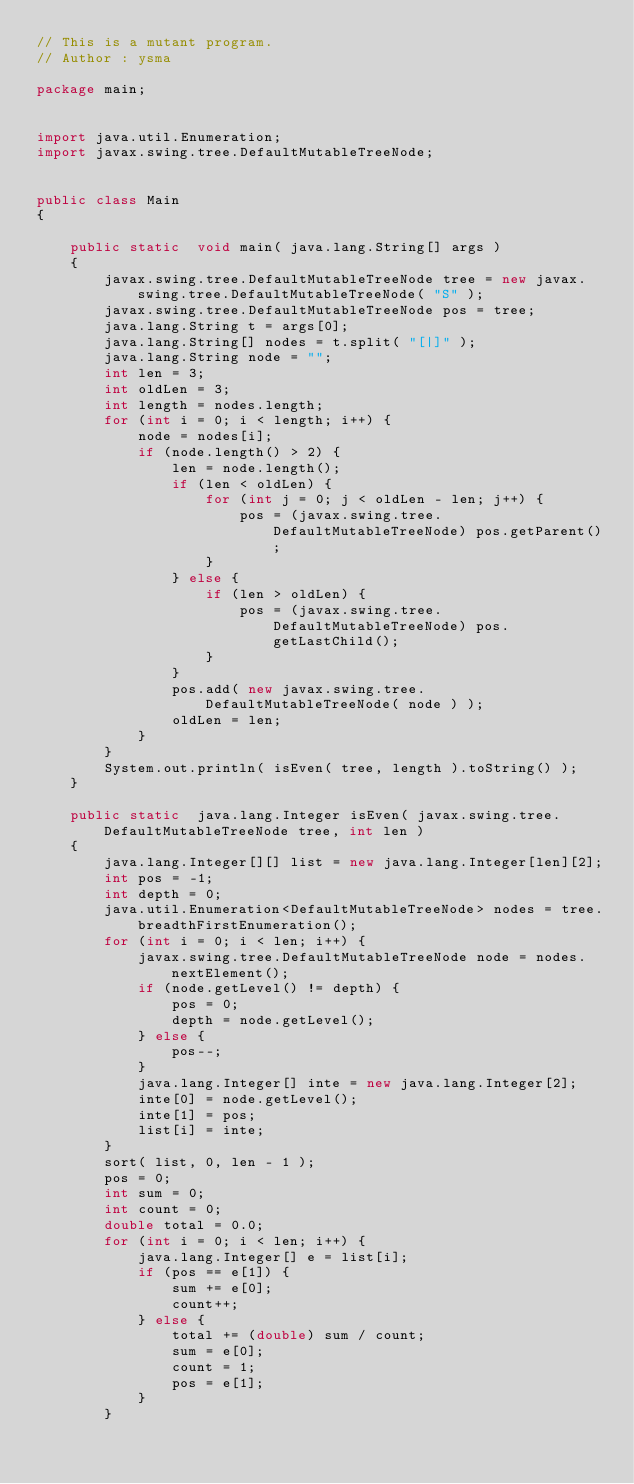Convert code to text. <code><loc_0><loc_0><loc_500><loc_500><_Java_>// This is a mutant program.
// Author : ysma

package main;


import java.util.Enumeration;
import javax.swing.tree.DefaultMutableTreeNode;


public class Main
{

    public static  void main( java.lang.String[] args )
    {
        javax.swing.tree.DefaultMutableTreeNode tree = new javax.swing.tree.DefaultMutableTreeNode( "S" );
        javax.swing.tree.DefaultMutableTreeNode pos = tree;
        java.lang.String t = args[0];
        java.lang.String[] nodes = t.split( "[|]" );
        java.lang.String node = "";
        int len = 3;
        int oldLen = 3;
        int length = nodes.length;
        for (int i = 0; i < length; i++) {
            node = nodes[i];
            if (node.length() > 2) {
                len = node.length();
                if (len < oldLen) {
                    for (int j = 0; j < oldLen - len; j++) {
                        pos = (javax.swing.tree.DefaultMutableTreeNode) pos.getParent();
                    }
                } else {
                    if (len > oldLen) {
                        pos = (javax.swing.tree.DefaultMutableTreeNode) pos.getLastChild();
                    }
                }
                pos.add( new javax.swing.tree.DefaultMutableTreeNode( node ) );
                oldLen = len;
            }
        }
        System.out.println( isEven( tree, length ).toString() );
    }

    public static  java.lang.Integer isEven( javax.swing.tree.DefaultMutableTreeNode tree, int len )
    {
        java.lang.Integer[][] list = new java.lang.Integer[len][2];
        int pos = -1;
        int depth = 0;
        java.util.Enumeration<DefaultMutableTreeNode> nodes = tree.breadthFirstEnumeration();
        for (int i = 0; i < len; i++) {
            javax.swing.tree.DefaultMutableTreeNode node = nodes.nextElement();
            if (node.getLevel() != depth) {
                pos = 0;
                depth = node.getLevel();
            } else {
                pos--;
            }
            java.lang.Integer[] inte = new java.lang.Integer[2];
            inte[0] = node.getLevel();
            inte[1] = pos;
            list[i] = inte;
        }
        sort( list, 0, len - 1 );
        pos = 0;
        int sum = 0;
        int count = 0;
        double total = 0.0;
        for (int i = 0; i < len; i++) {
            java.lang.Integer[] e = list[i];
            if (pos == e[1]) {
                sum += e[0];
                count++;
            } else {
                total += (double) sum / count;
                sum = e[0];
                count = 1;
                pos = e[1];
            }
        }</code> 